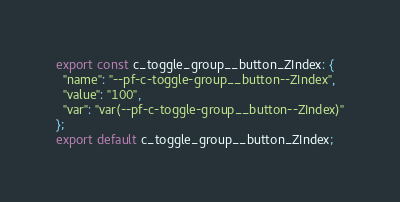<code> <loc_0><loc_0><loc_500><loc_500><_TypeScript_>export const c_toggle_group__button_ZIndex: {
  "name": "--pf-c-toggle-group__button--ZIndex",
  "value": "100",
  "var": "var(--pf-c-toggle-group__button--ZIndex)"
};
export default c_toggle_group__button_ZIndex;</code> 